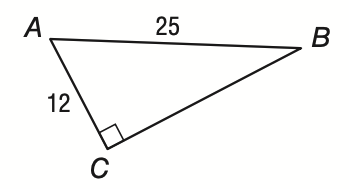Question: If A C = 12 and A B = 25, what is the measure of \angle B to the nearest tenth?
Choices:
A. 25.6
B. 28.7
C. 61.3
D. 64.4
Answer with the letter. Answer: B 